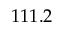<formula> <loc_0><loc_0><loc_500><loc_500>1 1 1 . 2</formula> 